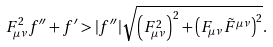Convert formula to latex. <formula><loc_0><loc_0><loc_500><loc_500>F _ { \mu \nu } ^ { 2 } f ^ { \prime \prime } + f ^ { \prime } > | f ^ { \prime \prime } | \sqrt { \left ( F _ { \mu \nu } ^ { 2 } \right ) ^ { 2 } + \left ( F _ { \mu \nu } \tilde { F } ^ { \mu \nu } \right ) ^ { 2 } } .</formula> 